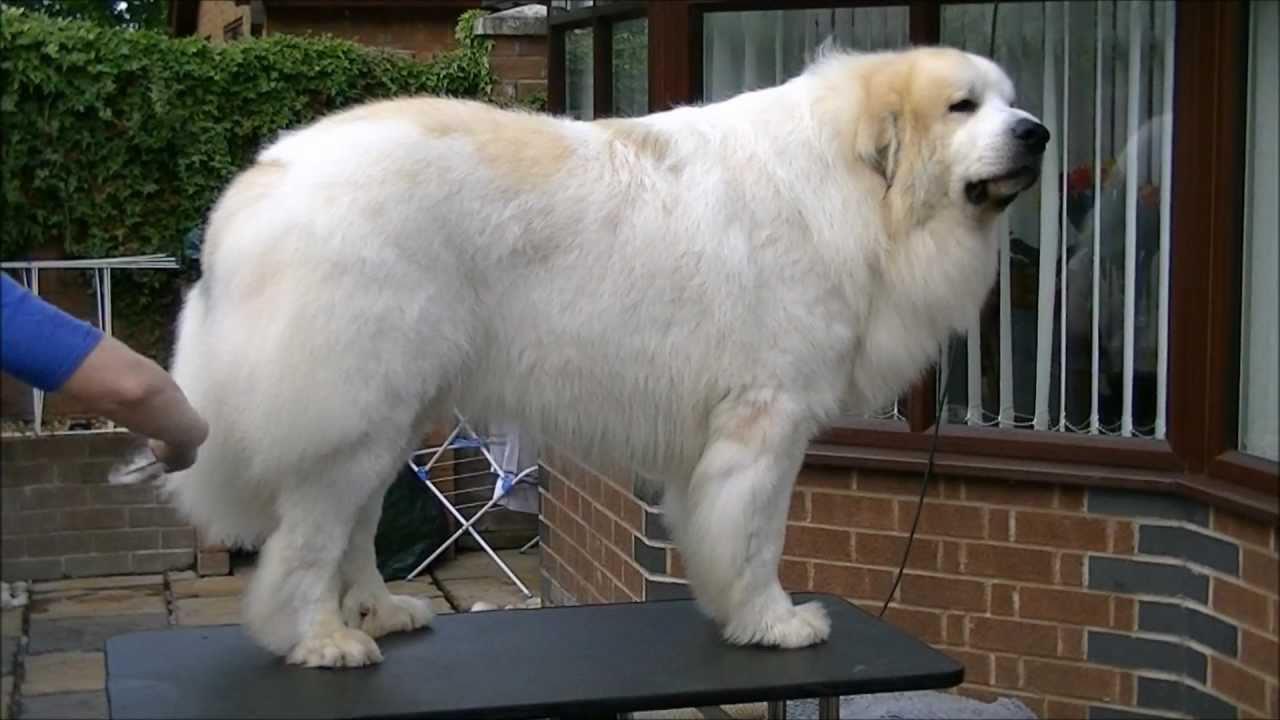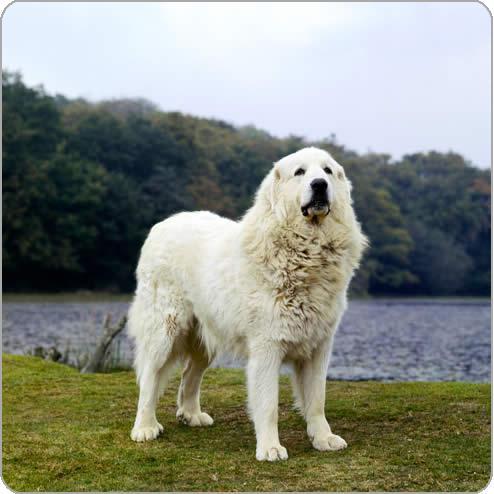The first image is the image on the left, the second image is the image on the right. For the images displayed, is the sentence "Exactly two large white dogs are standing upright." factually correct? Answer yes or no. Yes. The first image is the image on the left, the second image is the image on the right. For the images shown, is this caption "There are only two dogs and both are standing with at least one of them on green grass." true? Answer yes or no. Yes. The first image is the image on the left, the second image is the image on the right. Assess this claim about the two images: "Left image shows a dog standing in profile with body turned leftward.". Correct or not? Answer yes or no. No. 